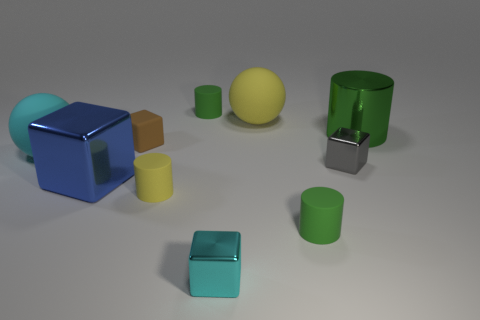There is a shiny cylinder; does it have the same color as the tiny cylinder behind the gray metallic thing?
Keep it short and to the point. Yes. What number of tiny cylinders have the same color as the large cylinder?
Your answer should be compact. 2. The cyan shiny thing is what shape?
Your response must be concise. Cube. What number of things are either big yellow rubber spheres or tiny green shiny things?
Offer a very short reply. 1. Do the yellow thing that is behind the tiny yellow matte thing and the green rubber thing in front of the large green metal thing have the same size?
Your answer should be compact. No. How many other objects are there of the same material as the cyan sphere?
Your response must be concise. 5. Are there more tiny yellow things that are to the left of the brown rubber block than tiny yellow rubber objects that are behind the large yellow rubber object?
Your answer should be compact. No. There is a cylinder behind the big green object; what is its material?
Keep it short and to the point. Rubber. Is the shape of the tiny brown thing the same as the blue shiny object?
Your answer should be compact. Yes. Is there anything else that is the same color as the big metallic cylinder?
Your response must be concise. Yes. 